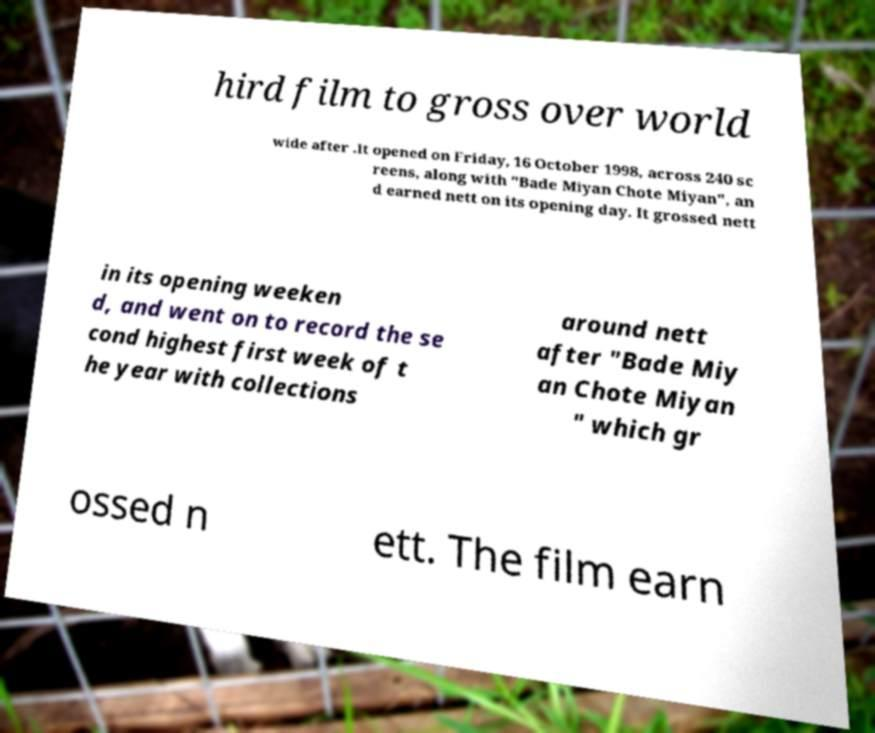Can you read and provide the text displayed in the image?This photo seems to have some interesting text. Can you extract and type it out for me? hird film to gross over world wide after .It opened on Friday, 16 October 1998, across 240 sc reens, along with "Bade Miyan Chote Miyan", an d earned nett on its opening day. It grossed nett in its opening weeken d, and went on to record the se cond highest first week of t he year with collections around nett after "Bade Miy an Chote Miyan " which gr ossed n ett. The film earn 